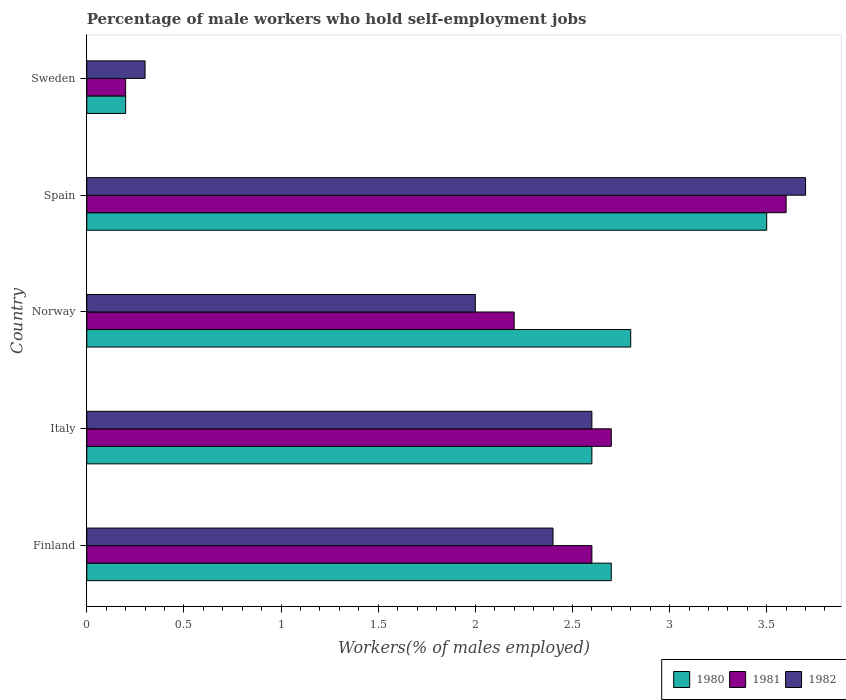How many groups of bars are there?
Give a very brief answer. 5. Are the number of bars per tick equal to the number of legend labels?
Offer a terse response. Yes. Are the number of bars on each tick of the Y-axis equal?
Your answer should be very brief. Yes. How many bars are there on the 3rd tick from the bottom?
Give a very brief answer. 3. In how many cases, is the number of bars for a given country not equal to the number of legend labels?
Offer a terse response. 0. What is the percentage of self-employed male workers in 1982 in Spain?
Provide a succinct answer. 3.7. Across all countries, what is the maximum percentage of self-employed male workers in 1982?
Ensure brevity in your answer.  3.7. Across all countries, what is the minimum percentage of self-employed male workers in 1981?
Offer a very short reply. 0.2. In which country was the percentage of self-employed male workers in 1980 maximum?
Give a very brief answer. Spain. What is the total percentage of self-employed male workers in 1982 in the graph?
Give a very brief answer. 11. What is the difference between the percentage of self-employed male workers in 1981 in Finland and that in Italy?
Give a very brief answer. -0.1. What is the difference between the percentage of self-employed male workers in 1980 in Finland and the percentage of self-employed male workers in 1982 in Sweden?
Offer a terse response. 2.4. What is the average percentage of self-employed male workers in 1982 per country?
Give a very brief answer. 2.2. What is the difference between the percentage of self-employed male workers in 1981 and percentage of self-employed male workers in 1982 in Norway?
Provide a short and direct response. 0.2. In how many countries, is the percentage of self-employed male workers in 1981 greater than 2.4 %?
Your answer should be compact. 3. What is the ratio of the percentage of self-employed male workers in 1981 in Finland to that in Norway?
Your response must be concise. 1.18. Is the percentage of self-employed male workers in 1981 in Italy less than that in Spain?
Make the answer very short. Yes. What is the difference between the highest and the second highest percentage of self-employed male workers in 1982?
Provide a short and direct response. 1.1. What is the difference between the highest and the lowest percentage of self-employed male workers in 1980?
Provide a succinct answer. 3.3. What does the 3rd bar from the top in Sweden represents?
Make the answer very short. 1980. How many bars are there?
Give a very brief answer. 15. Are all the bars in the graph horizontal?
Provide a short and direct response. Yes. What is the difference between two consecutive major ticks on the X-axis?
Ensure brevity in your answer.  0.5. Does the graph contain any zero values?
Keep it short and to the point. No. How are the legend labels stacked?
Give a very brief answer. Horizontal. What is the title of the graph?
Your answer should be very brief. Percentage of male workers who hold self-employment jobs. Does "2003" appear as one of the legend labels in the graph?
Your answer should be very brief. No. What is the label or title of the X-axis?
Make the answer very short. Workers(% of males employed). What is the label or title of the Y-axis?
Your answer should be very brief. Country. What is the Workers(% of males employed) in 1980 in Finland?
Your answer should be compact. 2.7. What is the Workers(% of males employed) in 1981 in Finland?
Your response must be concise. 2.6. What is the Workers(% of males employed) in 1982 in Finland?
Offer a terse response. 2.4. What is the Workers(% of males employed) in 1980 in Italy?
Offer a very short reply. 2.6. What is the Workers(% of males employed) in 1981 in Italy?
Provide a succinct answer. 2.7. What is the Workers(% of males employed) in 1982 in Italy?
Make the answer very short. 2.6. What is the Workers(% of males employed) in 1980 in Norway?
Your answer should be very brief. 2.8. What is the Workers(% of males employed) in 1981 in Norway?
Your answer should be compact. 2.2. What is the Workers(% of males employed) in 1981 in Spain?
Keep it short and to the point. 3.6. What is the Workers(% of males employed) of 1982 in Spain?
Make the answer very short. 3.7. What is the Workers(% of males employed) of 1980 in Sweden?
Give a very brief answer. 0.2. What is the Workers(% of males employed) in 1981 in Sweden?
Your answer should be very brief. 0.2. What is the Workers(% of males employed) of 1982 in Sweden?
Provide a short and direct response. 0.3. Across all countries, what is the maximum Workers(% of males employed) in 1980?
Your answer should be very brief. 3.5. Across all countries, what is the maximum Workers(% of males employed) in 1981?
Your answer should be compact. 3.6. Across all countries, what is the maximum Workers(% of males employed) of 1982?
Your answer should be compact. 3.7. Across all countries, what is the minimum Workers(% of males employed) in 1980?
Your answer should be very brief. 0.2. Across all countries, what is the minimum Workers(% of males employed) in 1981?
Offer a terse response. 0.2. Across all countries, what is the minimum Workers(% of males employed) in 1982?
Offer a very short reply. 0.3. What is the total Workers(% of males employed) of 1980 in the graph?
Ensure brevity in your answer.  11.8. What is the total Workers(% of males employed) in 1981 in the graph?
Your answer should be compact. 11.3. What is the difference between the Workers(% of males employed) of 1981 in Finland and that in Italy?
Offer a terse response. -0.1. What is the difference between the Workers(% of males employed) in 1982 in Finland and that in Italy?
Your answer should be very brief. -0.2. What is the difference between the Workers(% of males employed) of 1982 in Finland and that in Norway?
Provide a succinct answer. 0.4. What is the difference between the Workers(% of males employed) in 1980 in Finland and that in Spain?
Ensure brevity in your answer.  -0.8. What is the difference between the Workers(% of males employed) in 1981 in Finland and that in Spain?
Ensure brevity in your answer.  -1. What is the difference between the Workers(% of males employed) in 1982 in Finland and that in Spain?
Offer a very short reply. -1.3. What is the difference between the Workers(% of males employed) of 1980 in Finland and that in Sweden?
Your answer should be compact. 2.5. What is the difference between the Workers(% of males employed) of 1982 in Finland and that in Sweden?
Make the answer very short. 2.1. What is the difference between the Workers(% of males employed) in 1980 in Italy and that in Norway?
Your answer should be compact. -0.2. What is the difference between the Workers(% of males employed) of 1981 in Italy and that in Spain?
Provide a succinct answer. -0.9. What is the difference between the Workers(% of males employed) in 1982 in Italy and that in Spain?
Offer a very short reply. -1.1. What is the difference between the Workers(% of males employed) in 1980 in Italy and that in Sweden?
Offer a terse response. 2.4. What is the difference between the Workers(% of males employed) in 1981 in Norway and that in Spain?
Your response must be concise. -1.4. What is the difference between the Workers(% of males employed) in 1981 in Norway and that in Sweden?
Offer a very short reply. 2. What is the difference between the Workers(% of males employed) in 1982 in Norway and that in Sweden?
Offer a terse response. 1.7. What is the difference between the Workers(% of males employed) in 1980 in Finland and the Workers(% of males employed) in 1981 in Italy?
Offer a very short reply. 0. What is the difference between the Workers(% of males employed) in 1980 in Finland and the Workers(% of males employed) in 1982 in Italy?
Your response must be concise. 0.1. What is the difference between the Workers(% of males employed) in 1981 in Finland and the Workers(% of males employed) in 1982 in Italy?
Offer a very short reply. 0. What is the difference between the Workers(% of males employed) in 1981 in Finland and the Workers(% of males employed) in 1982 in Norway?
Ensure brevity in your answer.  0.6. What is the difference between the Workers(% of males employed) in 1980 in Finland and the Workers(% of males employed) in 1982 in Spain?
Offer a terse response. -1. What is the difference between the Workers(% of males employed) in 1980 in Finland and the Workers(% of males employed) in 1982 in Sweden?
Provide a short and direct response. 2.4. What is the difference between the Workers(% of males employed) of 1980 in Italy and the Workers(% of males employed) of 1981 in Norway?
Provide a succinct answer. 0.4. What is the difference between the Workers(% of males employed) in 1980 in Italy and the Workers(% of males employed) in 1982 in Norway?
Provide a short and direct response. 0.6. What is the difference between the Workers(% of males employed) in 1981 in Italy and the Workers(% of males employed) in 1982 in Norway?
Make the answer very short. 0.7. What is the difference between the Workers(% of males employed) in 1980 in Italy and the Workers(% of males employed) in 1981 in Spain?
Ensure brevity in your answer.  -1. What is the difference between the Workers(% of males employed) in 1980 in Italy and the Workers(% of males employed) in 1982 in Spain?
Provide a short and direct response. -1.1. What is the difference between the Workers(% of males employed) of 1980 in Italy and the Workers(% of males employed) of 1982 in Sweden?
Ensure brevity in your answer.  2.3. What is the difference between the Workers(% of males employed) in 1981 in Italy and the Workers(% of males employed) in 1982 in Sweden?
Keep it short and to the point. 2.4. What is the difference between the Workers(% of males employed) in 1980 in Norway and the Workers(% of males employed) in 1981 in Spain?
Your answer should be compact. -0.8. What is the difference between the Workers(% of males employed) of 1981 in Norway and the Workers(% of males employed) of 1982 in Spain?
Keep it short and to the point. -1.5. What is the difference between the Workers(% of males employed) in 1980 in Norway and the Workers(% of males employed) in 1982 in Sweden?
Your answer should be compact. 2.5. What is the difference between the Workers(% of males employed) in 1980 in Spain and the Workers(% of males employed) in 1981 in Sweden?
Provide a short and direct response. 3.3. What is the difference between the Workers(% of males employed) of 1981 in Spain and the Workers(% of males employed) of 1982 in Sweden?
Offer a very short reply. 3.3. What is the average Workers(% of males employed) of 1980 per country?
Provide a succinct answer. 2.36. What is the average Workers(% of males employed) of 1981 per country?
Offer a terse response. 2.26. What is the difference between the Workers(% of males employed) of 1980 and Workers(% of males employed) of 1981 in Finland?
Your answer should be very brief. 0.1. What is the difference between the Workers(% of males employed) of 1980 and Workers(% of males employed) of 1981 in Italy?
Your response must be concise. -0.1. What is the difference between the Workers(% of males employed) in 1980 and Workers(% of males employed) in 1982 in Italy?
Offer a very short reply. 0. What is the difference between the Workers(% of males employed) of 1980 and Workers(% of males employed) of 1981 in Norway?
Ensure brevity in your answer.  0.6. What is the difference between the Workers(% of males employed) in 1981 and Workers(% of males employed) in 1982 in Norway?
Keep it short and to the point. 0.2. What is the difference between the Workers(% of males employed) of 1981 and Workers(% of males employed) of 1982 in Spain?
Provide a short and direct response. -0.1. What is the difference between the Workers(% of males employed) in 1980 and Workers(% of males employed) in 1981 in Sweden?
Your answer should be very brief. 0. What is the difference between the Workers(% of males employed) in 1980 and Workers(% of males employed) in 1982 in Sweden?
Ensure brevity in your answer.  -0.1. What is the ratio of the Workers(% of males employed) of 1980 in Finland to that in Italy?
Ensure brevity in your answer.  1.04. What is the ratio of the Workers(% of males employed) of 1982 in Finland to that in Italy?
Ensure brevity in your answer.  0.92. What is the ratio of the Workers(% of males employed) of 1981 in Finland to that in Norway?
Make the answer very short. 1.18. What is the ratio of the Workers(% of males employed) in 1982 in Finland to that in Norway?
Give a very brief answer. 1.2. What is the ratio of the Workers(% of males employed) in 1980 in Finland to that in Spain?
Give a very brief answer. 0.77. What is the ratio of the Workers(% of males employed) of 1981 in Finland to that in Spain?
Offer a terse response. 0.72. What is the ratio of the Workers(% of males employed) in 1982 in Finland to that in Spain?
Make the answer very short. 0.65. What is the ratio of the Workers(% of males employed) in 1980 in Finland to that in Sweden?
Your response must be concise. 13.5. What is the ratio of the Workers(% of males employed) of 1981 in Finland to that in Sweden?
Provide a short and direct response. 13. What is the ratio of the Workers(% of males employed) of 1982 in Finland to that in Sweden?
Keep it short and to the point. 8. What is the ratio of the Workers(% of males employed) in 1980 in Italy to that in Norway?
Offer a very short reply. 0.93. What is the ratio of the Workers(% of males employed) in 1981 in Italy to that in Norway?
Offer a terse response. 1.23. What is the ratio of the Workers(% of males employed) in 1980 in Italy to that in Spain?
Your answer should be compact. 0.74. What is the ratio of the Workers(% of males employed) in 1981 in Italy to that in Spain?
Ensure brevity in your answer.  0.75. What is the ratio of the Workers(% of males employed) of 1982 in Italy to that in Spain?
Your response must be concise. 0.7. What is the ratio of the Workers(% of males employed) in 1982 in Italy to that in Sweden?
Offer a terse response. 8.67. What is the ratio of the Workers(% of males employed) in 1980 in Norway to that in Spain?
Your answer should be compact. 0.8. What is the ratio of the Workers(% of males employed) of 1981 in Norway to that in Spain?
Your answer should be compact. 0.61. What is the ratio of the Workers(% of males employed) in 1982 in Norway to that in Spain?
Offer a very short reply. 0.54. What is the ratio of the Workers(% of males employed) in 1982 in Spain to that in Sweden?
Your answer should be very brief. 12.33. What is the difference between the highest and the second highest Workers(% of males employed) of 1981?
Give a very brief answer. 0.9. What is the difference between the highest and the second highest Workers(% of males employed) of 1982?
Make the answer very short. 1.1. What is the difference between the highest and the lowest Workers(% of males employed) of 1980?
Ensure brevity in your answer.  3.3. What is the difference between the highest and the lowest Workers(% of males employed) in 1981?
Ensure brevity in your answer.  3.4. 